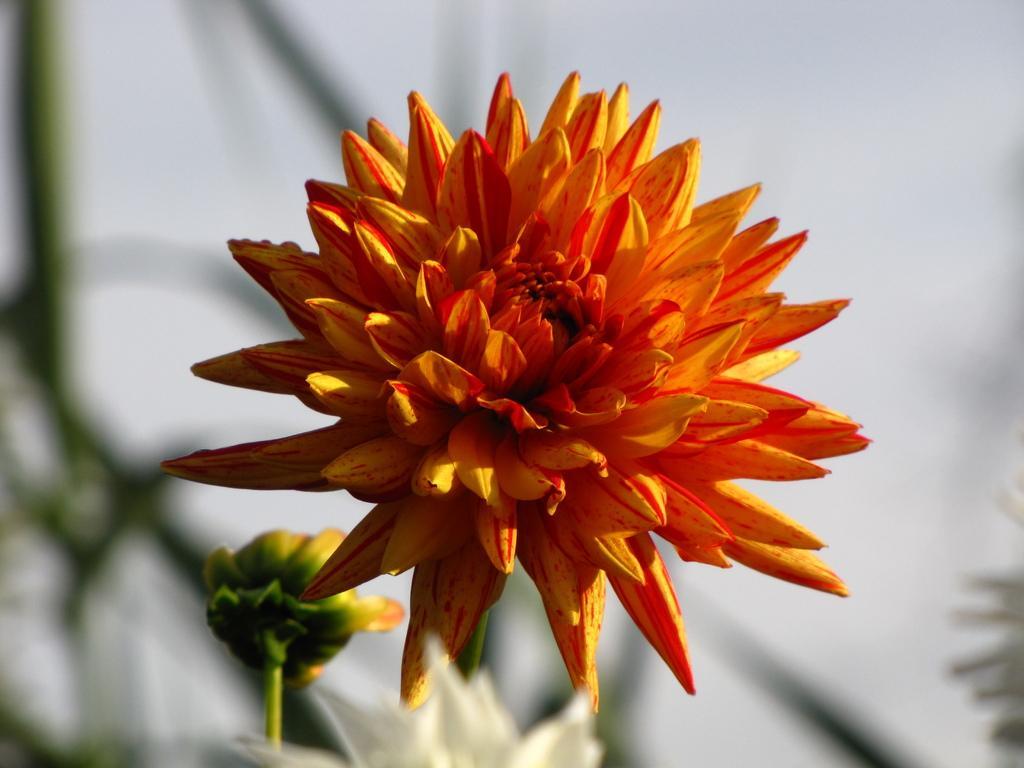Please provide a concise description of this image. In front of the picture, we see a flower in yellow and orange color. In the background, we see the flowers in yellow and white color. In the background, it is in white and green color. This picture is blurred in the background. 